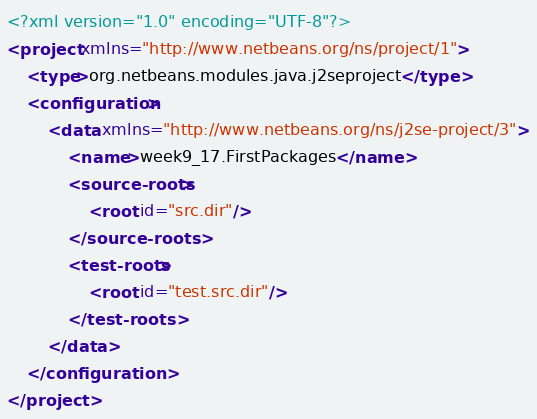<code> <loc_0><loc_0><loc_500><loc_500><_XML_><?xml version="1.0" encoding="UTF-8"?>
<project xmlns="http://www.netbeans.org/ns/project/1">
    <type>org.netbeans.modules.java.j2seproject</type>
    <configuration>
        <data xmlns="http://www.netbeans.org/ns/j2se-project/3">
            <name>week9_17.FirstPackages</name>
            <source-roots>
                <root id="src.dir"/>
            </source-roots>
            <test-roots>
                <root id="test.src.dir"/>
            </test-roots>
        </data>
    </configuration>
</project>
</code> 